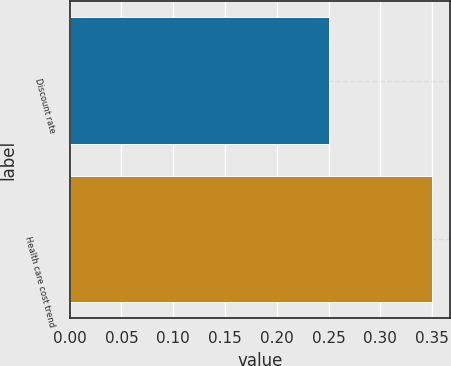Convert chart to OTSL. <chart><loc_0><loc_0><loc_500><loc_500><bar_chart><fcel>Discount rate<fcel>Health care cost trend<nl><fcel>0.25<fcel>0.35<nl></chart> 